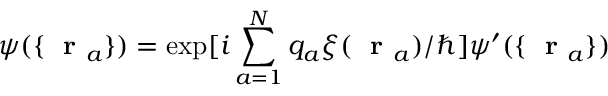<formula> <loc_0><loc_0><loc_500><loc_500>\psi ( \{ r _ { a } \} ) = \exp [ i \sum _ { a = 1 } ^ { N } q _ { a } \xi ( r _ { a } ) / \hbar { ] } \psi ^ { \prime } ( \{ r _ { a } \} )</formula> 